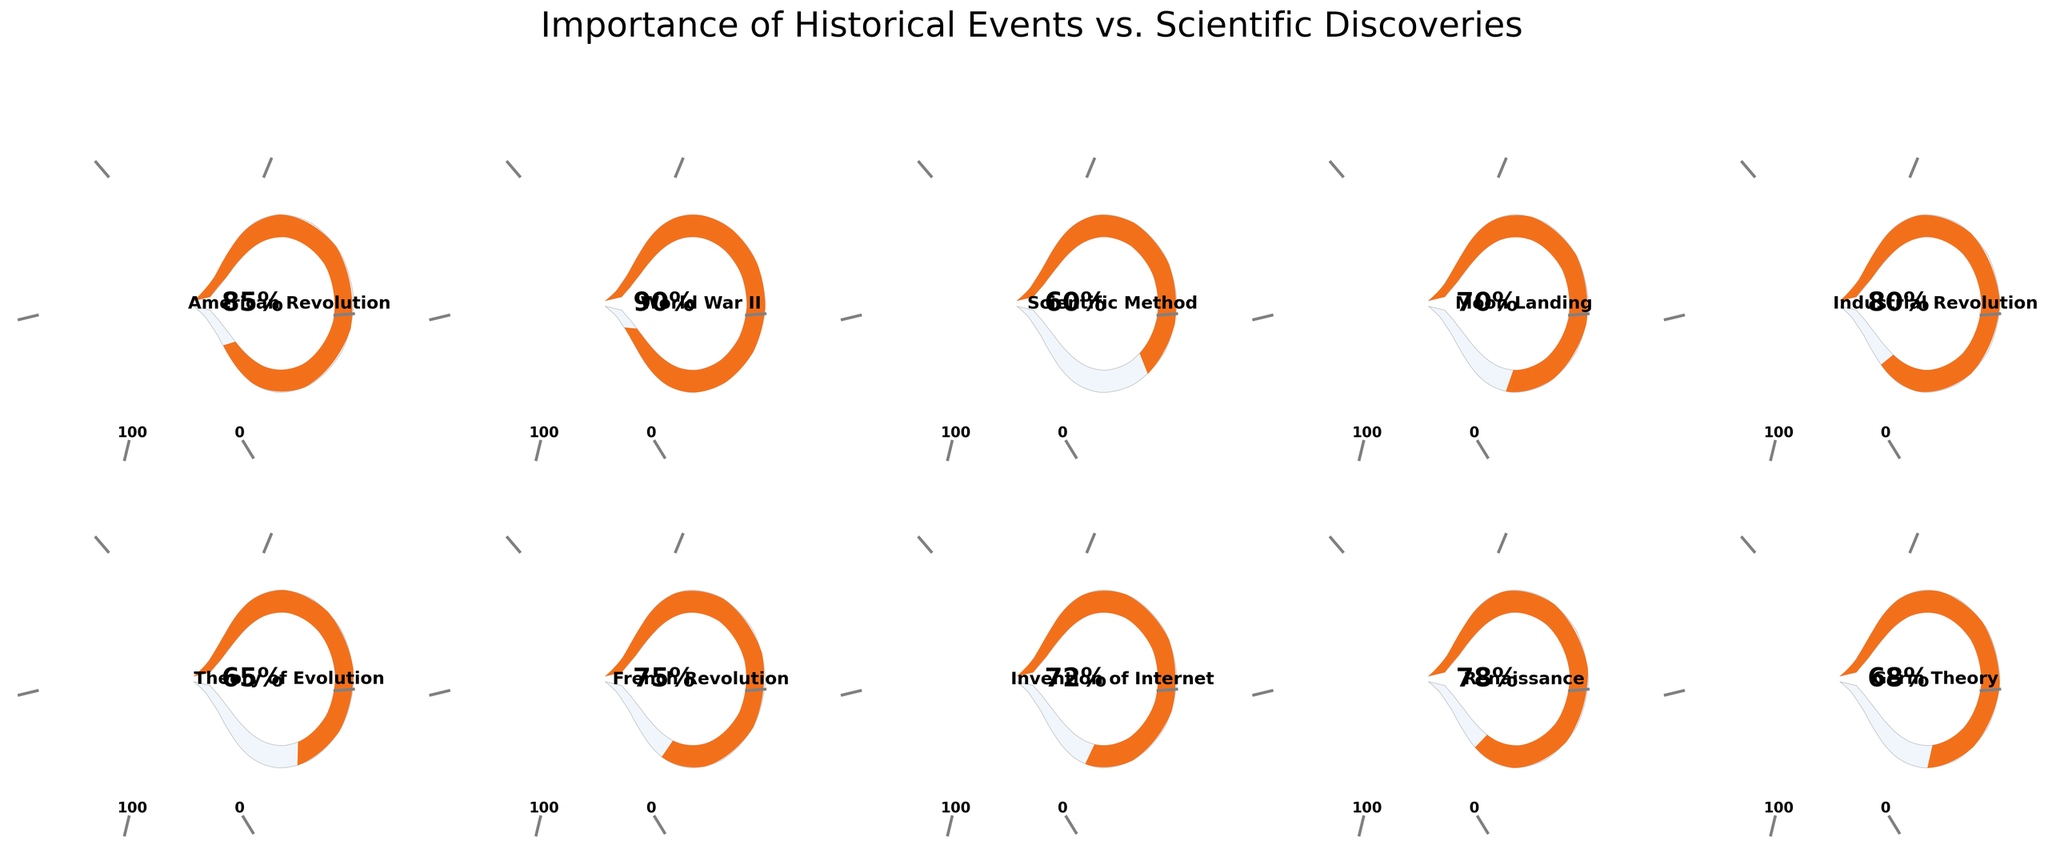What's the most important event according to the public opinion shown in the figure? To determine the most important event, we need to look at the gauge chart with the highest percentage value. The chart shows that World War II has the highest value at 90%.
Answer: World War II What's the least important scientific discovery according to the figure? The gauge charts indicate the importance values. From the scientific discoveries listed (Scientific Method, Moon Landing, Theory of Evolution, Invention of Internet, Germ Theory), the Scientific Method has the lowest score at 60%.
Answer: Scientific Method What's the average importance of historical events excluding scientific discoveries? Summing the importance values of historical events (85 + 90 + 80 + 75 + 78) equals 408. Dividing by the number of historical events, 408/5 = 81.6.
Answer: 81.6 Which historical event is considered more important: the Renaissance or the French Revolution? Comparing the gauge values for both events, the Renaissance (78%) is slightly more important than the French Revolution (75%).
Answer: Renaissance How many events or discoveries had an importance value above 70%? Gauge charts show the events with values above 70%: American Revolution (85%), World War II (90%), Moon Landing (70%), Industrial Revolution (80%), French Revolution (75%), Invention of Internet (72%), and Renaissance (78%). There are 7 such events.
Answer: 7 What is the difference in importance between the Industrial Revolution and Germ Theory? Importance for Industrial Revolution (80%) minus importance for Germ Theory (68%) gives us a difference of 12%.
Answer: 12% Does the Moon Landing rank higher in importance than the Theory of Evolution? By comparing the gauges, the Moon Landing at 70% is higher than the Theory of Evolution at 65%.
Answer: Yes What's the title of the figure? The title positioned at the top of the figure reads "Importance of Historical Events vs. Scientific Discoveries."
Answer: Importance of Historical Events vs. Scientific Discoveries Which has a higher importance, the Scientific Method or the Invention of the Internet? From the gauge charts, the Invention of the Internet (72%) is considered more important than the Scientific Method (60%).
Answer: Invention of the Internet 